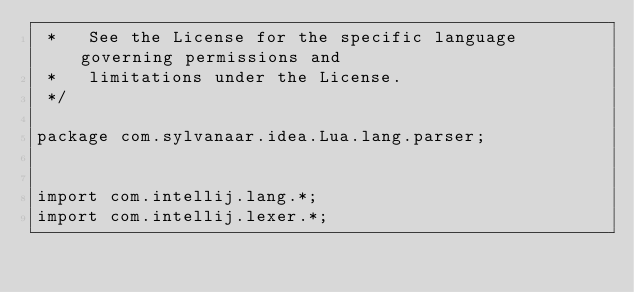Convert code to text. <code><loc_0><loc_0><loc_500><loc_500><_Java_> *   See the License for the specific language governing permissions and
 *   limitations under the License.
 */

package com.sylvanaar.idea.Lua.lang.parser;


import com.intellij.lang.*;
import com.intellij.lexer.*;</code> 